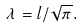<formula> <loc_0><loc_0><loc_500><loc_500>\lambda = l / \sqrt { \pi } .</formula> 